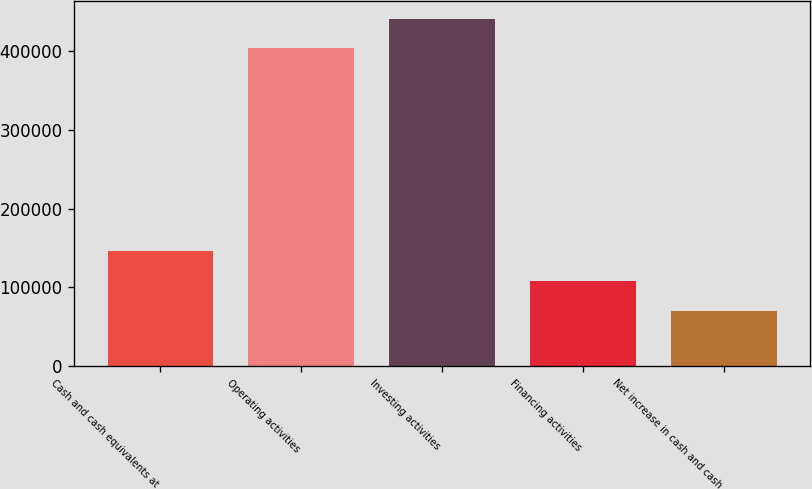<chart> <loc_0><loc_0><loc_500><loc_500><bar_chart><fcel>Cash and cash equivalents at<fcel>Operating activities<fcel>Investing activities<fcel>Financing activities<fcel>Net increase in cash and cash<nl><fcel>145626<fcel>403880<fcel>441652<fcel>107855<fcel>70083.5<nl></chart> 